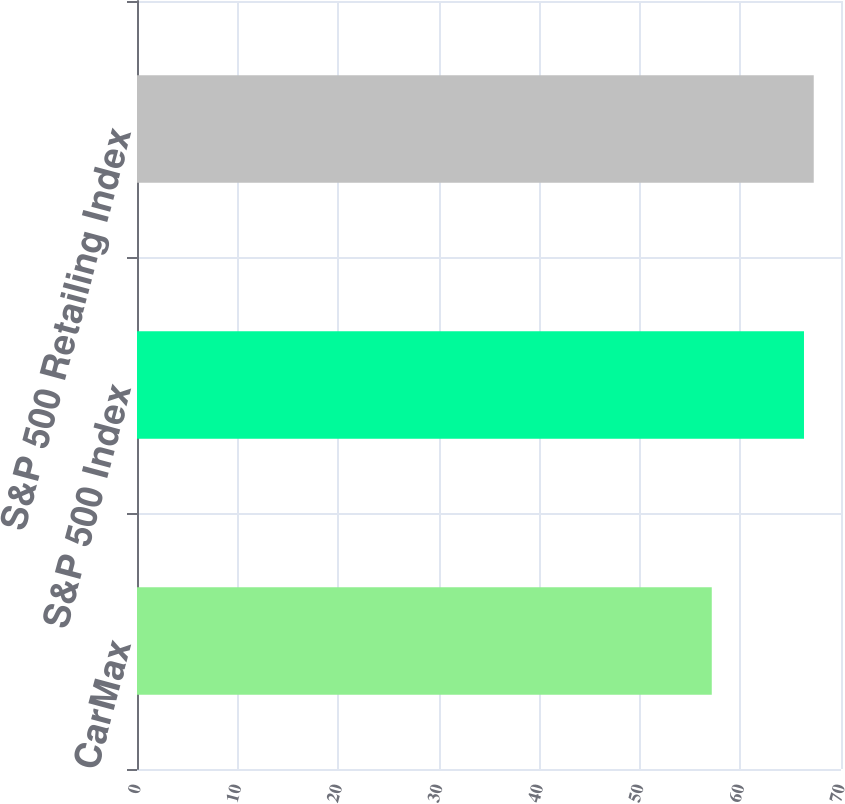Convert chart to OTSL. <chart><loc_0><loc_0><loc_500><loc_500><bar_chart><fcel>CarMax<fcel>S&P 500 Index<fcel>S&P 500 Retailing Index<nl><fcel>57.15<fcel>66.32<fcel>67.29<nl></chart> 